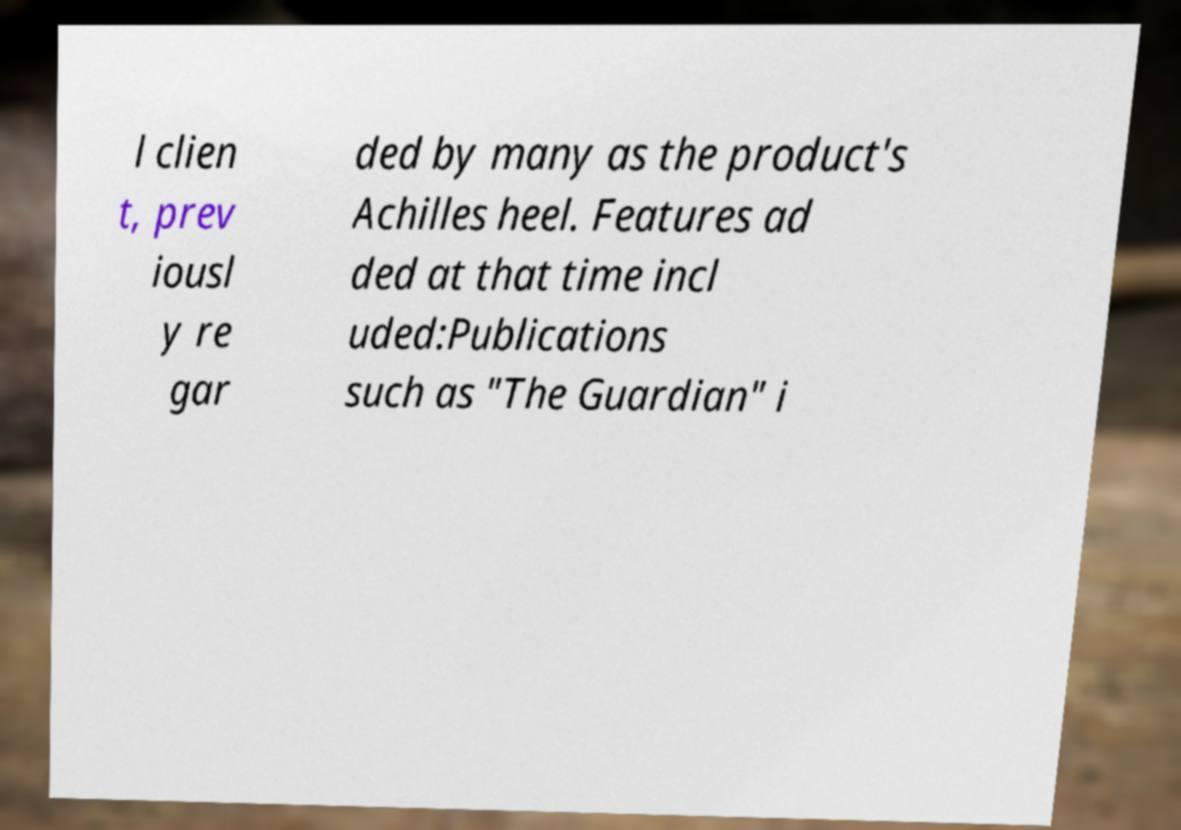Please read and relay the text visible in this image. What does it say? l clien t, prev iousl y re gar ded by many as the product's Achilles heel. Features ad ded at that time incl uded:Publications such as "The Guardian" i 